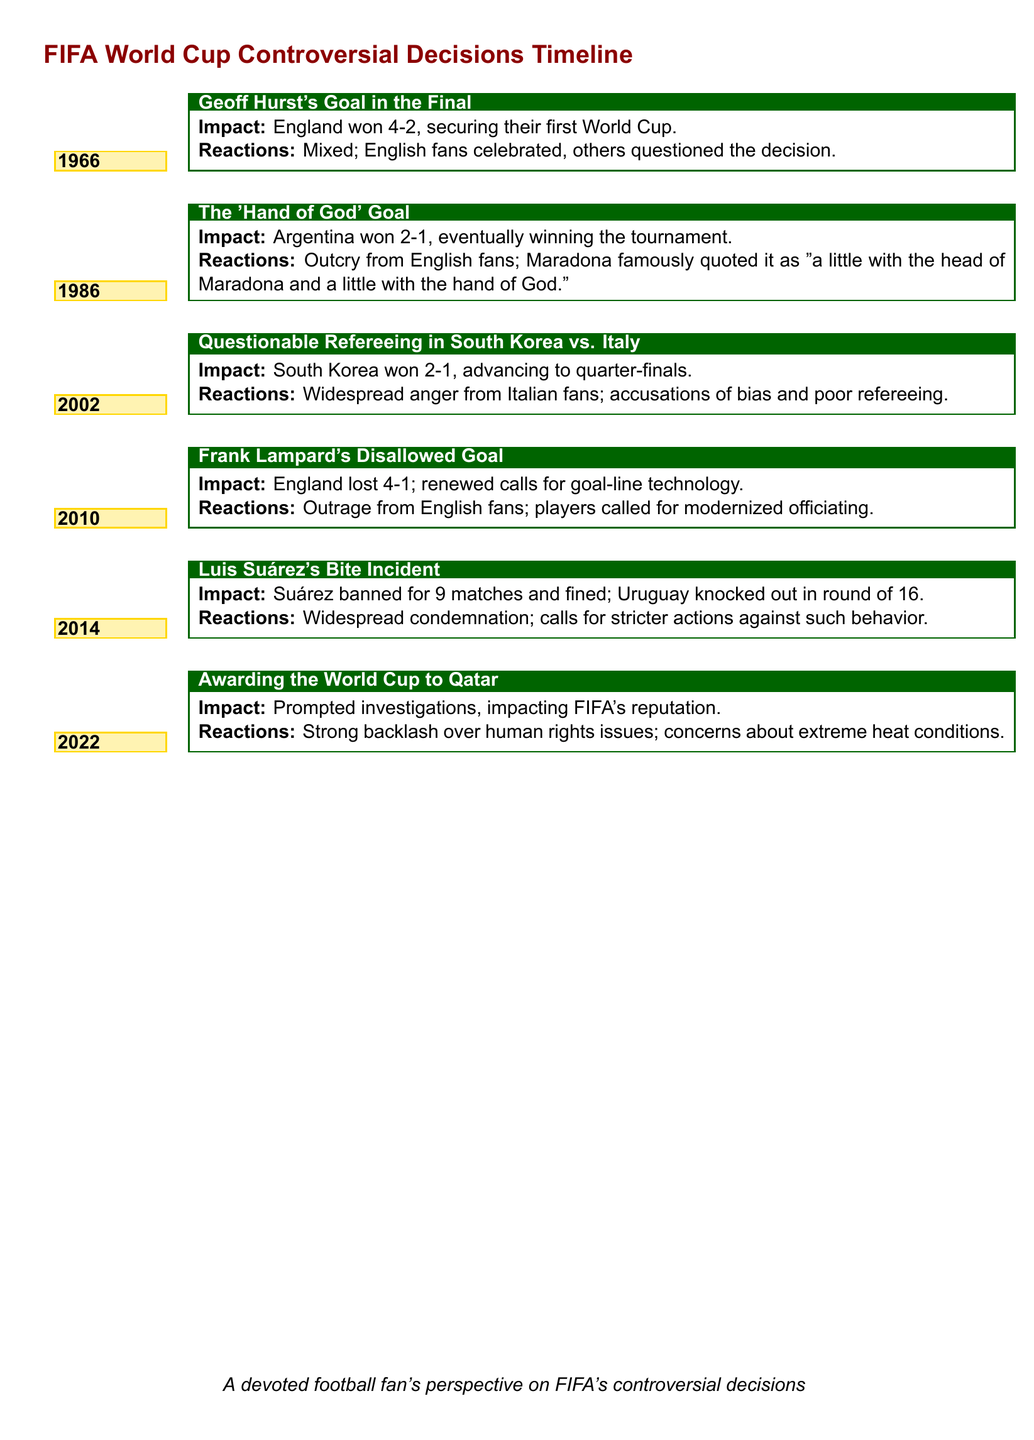What year did Geoff Hurst's goal occur? The year is mentioned in the timeline under Geoff Hurst's goal event.
Answer: 1966 What was the result of the match where Argentina scored the 'Hand of God' goal? The document states the match result of Argentina's 'Hand of God' goal.
Answer: 2-1 Who was banned for 9 matches in 2014? The timeline details the incident involving a player banned for misconduct.
Answer: Luis Suárez In what year was Frank Lampard's goal disallowed? The year is indicated in the timeline adjacent to the disallowed goal event.
Answer: 2010 What significant technology was called for after Frank Lampard's disallowed goal? The document highlights a specific technological demand following the controversial decision.
Answer: Goal-line technology What was the public reaction to the awarding of the World Cup to Qatar? The public response regarding FIFA's decision on Qatar's World Cup hosting is summarized.
Answer: Strong backlash What did the 'Hand of God' goal impact? The impact of the goal is described in relation to the tournament's outcome.
Answer: Argentina won the tournament What did the questionable refereeing in 2002 lead to? The impact of the controversial refereeing is noted in terms of team advancement.
Answer: South Korea advanced to quarter-finals What common theme is discussed across multiple incidents in the document? The document implies a recurring issue that arises in FIFA decisions based on player and public reactions.
Answer: Discontent and controversy 